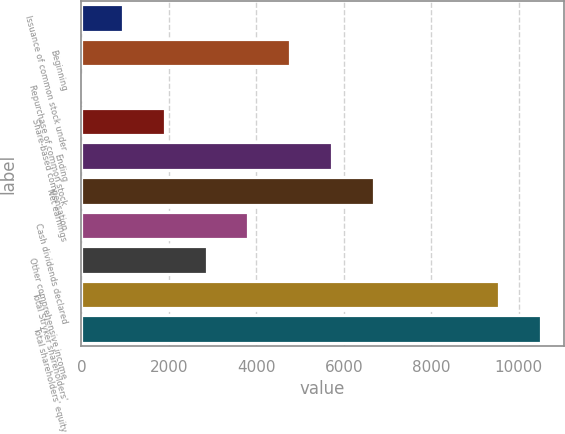<chart> <loc_0><loc_0><loc_500><loc_500><bar_chart><fcel>Issuance of common stock under<fcel>Beginning<fcel>Repurchase of common stock<fcel>Share-based compensation<fcel>Ending<fcel>Net earnings<fcel>Cash dividends declared<fcel>Other comprehensive income<fcel>Total Stryker shareholders'<fcel>Total shareholders' equity<nl><fcel>955.9<fcel>4775.5<fcel>1<fcel>1910.8<fcel>5730.4<fcel>6685.3<fcel>3820.6<fcel>2865.7<fcel>9550<fcel>10504.9<nl></chart> 